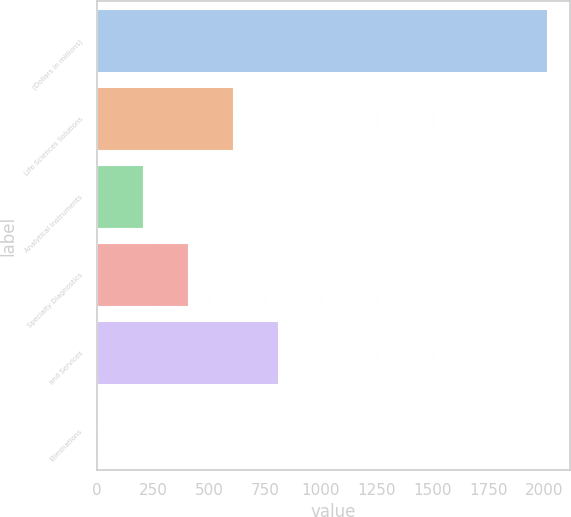<chart> <loc_0><loc_0><loc_500><loc_500><bar_chart><fcel>(Dollars in millions)<fcel>Life Sciences Solutions<fcel>Analytical Instruments<fcel>Specialty Diagnostics<fcel>and Services<fcel>Eliminations<nl><fcel>2014<fcel>606.3<fcel>204.1<fcel>405.2<fcel>807.4<fcel>3<nl></chart> 